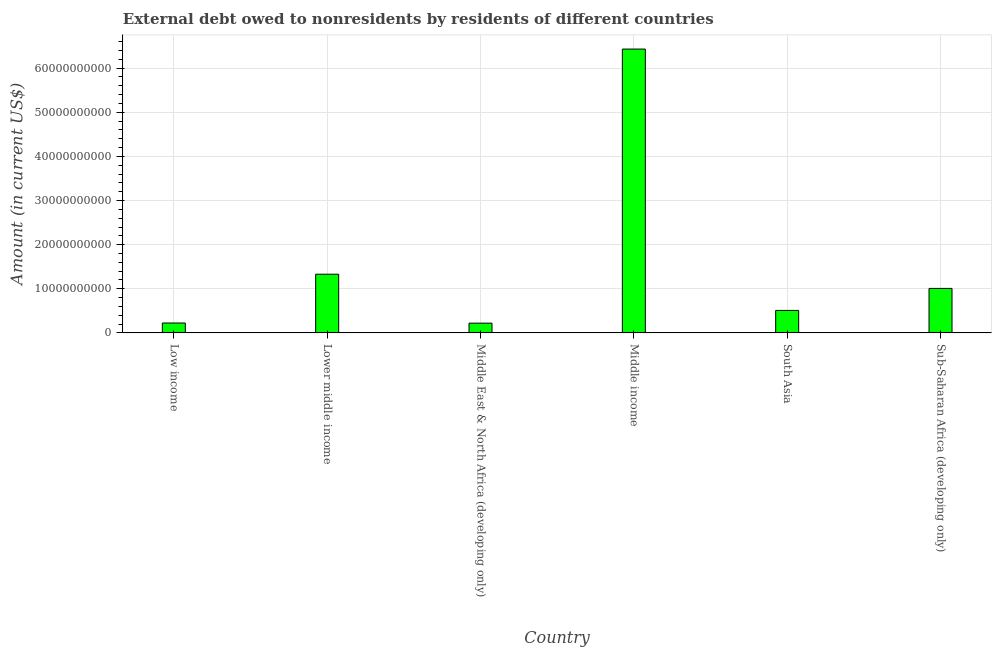Does the graph contain grids?
Your answer should be compact. Yes. What is the title of the graph?
Make the answer very short. External debt owed to nonresidents by residents of different countries. What is the label or title of the Y-axis?
Offer a terse response. Amount (in current US$). What is the debt in Middle East & North Africa (developing only)?
Give a very brief answer. 2.22e+09. Across all countries, what is the maximum debt?
Provide a succinct answer. 6.43e+1. Across all countries, what is the minimum debt?
Provide a succinct answer. 2.22e+09. In which country was the debt maximum?
Give a very brief answer. Middle income. In which country was the debt minimum?
Provide a short and direct response. Middle East & North Africa (developing only). What is the sum of the debt?
Give a very brief answer. 9.73e+1. What is the difference between the debt in Middle income and Sub-Saharan Africa (developing only)?
Provide a short and direct response. 5.42e+1. What is the average debt per country?
Your response must be concise. 1.62e+1. What is the median debt?
Provide a succinct answer. 7.60e+09. In how many countries, is the debt greater than 62000000000 US$?
Give a very brief answer. 1. What is the ratio of the debt in Low income to that in Middle income?
Your response must be concise. 0.04. Is the debt in Low income less than that in Sub-Saharan Africa (developing only)?
Provide a short and direct response. Yes. What is the difference between the highest and the second highest debt?
Keep it short and to the point. 5.10e+1. What is the difference between the highest and the lowest debt?
Your response must be concise. 6.21e+1. Are all the bars in the graph horizontal?
Your answer should be very brief. No. What is the Amount (in current US$) in Low income?
Ensure brevity in your answer.  2.25e+09. What is the Amount (in current US$) in Lower middle income?
Make the answer very short. 1.33e+1. What is the Amount (in current US$) of Middle East & North Africa (developing only)?
Your answer should be compact. 2.22e+09. What is the Amount (in current US$) of Middle income?
Provide a short and direct response. 6.43e+1. What is the Amount (in current US$) in South Asia?
Your answer should be compact. 5.10e+09. What is the Amount (in current US$) of Sub-Saharan Africa (developing only)?
Provide a succinct answer. 1.01e+1. What is the difference between the Amount (in current US$) in Low income and Lower middle income?
Offer a very short reply. -1.11e+1. What is the difference between the Amount (in current US$) in Low income and Middle East & North Africa (developing only)?
Offer a very short reply. 3.30e+07. What is the difference between the Amount (in current US$) in Low income and Middle income?
Your answer should be very brief. -6.21e+1. What is the difference between the Amount (in current US$) in Low income and South Asia?
Give a very brief answer. -2.85e+09. What is the difference between the Amount (in current US$) in Low income and Sub-Saharan Africa (developing only)?
Your response must be concise. -7.84e+09. What is the difference between the Amount (in current US$) in Lower middle income and Middle East & North Africa (developing only)?
Provide a succinct answer. 1.11e+1. What is the difference between the Amount (in current US$) in Lower middle income and Middle income?
Your response must be concise. -5.10e+1. What is the difference between the Amount (in current US$) in Lower middle income and South Asia?
Provide a succinct answer. 8.20e+09. What is the difference between the Amount (in current US$) in Lower middle income and Sub-Saharan Africa (developing only)?
Offer a terse response. 3.22e+09. What is the difference between the Amount (in current US$) in Middle East & North Africa (developing only) and Middle income?
Keep it short and to the point. -6.21e+1. What is the difference between the Amount (in current US$) in Middle East & North Africa (developing only) and South Asia?
Ensure brevity in your answer.  -2.88e+09. What is the difference between the Amount (in current US$) in Middle East & North Africa (developing only) and Sub-Saharan Africa (developing only)?
Keep it short and to the point. -7.87e+09. What is the difference between the Amount (in current US$) in Middle income and South Asia?
Ensure brevity in your answer.  5.92e+1. What is the difference between the Amount (in current US$) in Middle income and Sub-Saharan Africa (developing only)?
Ensure brevity in your answer.  5.42e+1. What is the difference between the Amount (in current US$) in South Asia and Sub-Saharan Africa (developing only)?
Your response must be concise. -4.98e+09. What is the ratio of the Amount (in current US$) in Low income to that in Lower middle income?
Provide a short and direct response. 0.17. What is the ratio of the Amount (in current US$) in Low income to that in Middle income?
Your answer should be compact. 0.04. What is the ratio of the Amount (in current US$) in Low income to that in South Asia?
Offer a very short reply. 0.44. What is the ratio of the Amount (in current US$) in Low income to that in Sub-Saharan Africa (developing only)?
Provide a short and direct response. 0.22. What is the ratio of the Amount (in current US$) in Lower middle income to that in Middle East & North Africa (developing only)?
Your answer should be very brief. 5.99. What is the ratio of the Amount (in current US$) in Lower middle income to that in Middle income?
Make the answer very short. 0.21. What is the ratio of the Amount (in current US$) in Lower middle income to that in South Asia?
Your answer should be very brief. 2.61. What is the ratio of the Amount (in current US$) in Lower middle income to that in Sub-Saharan Africa (developing only)?
Offer a very short reply. 1.32. What is the ratio of the Amount (in current US$) in Middle East & North Africa (developing only) to that in Middle income?
Ensure brevity in your answer.  0.04. What is the ratio of the Amount (in current US$) in Middle East & North Africa (developing only) to that in South Asia?
Your answer should be compact. 0.43. What is the ratio of the Amount (in current US$) in Middle East & North Africa (developing only) to that in Sub-Saharan Africa (developing only)?
Your response must be concise. 0.22. What is the ratio of the Amount (in current US$) in Middle income to that in South Asia?
Offer a terse response. 12.6. What is the ratio of the Amount (in current US$) in Middle income to that in Sub-Saharan Africa (developing only)?
Make the answer very short. 6.38. What is the ratio of the Amount (in current US$) in South Asia to that in Sub-Saharan Africa (developing only)?
Provide a succinct answer. 0.51. 